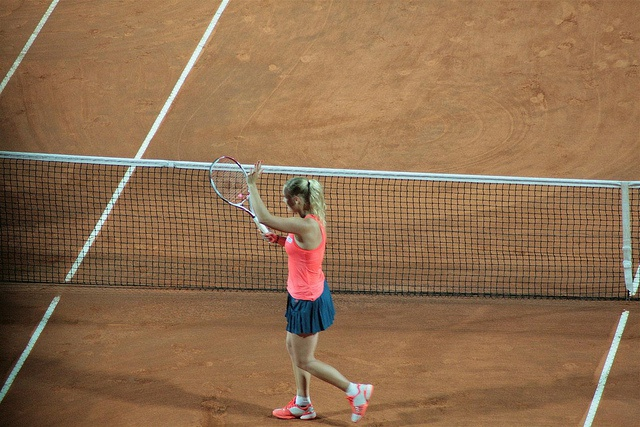Describe the objects in this image and their specific colors. I can see people in gray, darkgray, salmon, and tan tones and tennis racket in gray, tan, and darkgray tones in this image. 